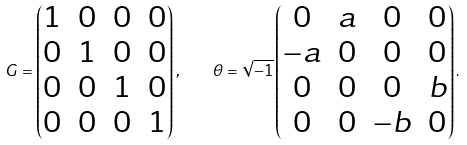<formula> <loc_0><loc_0><loc_500><loc_500>G = \begin{pmatrix} 1 & 0 & 0 & 0 \\ 0 & 1 & 0 & 0 \\ 0 & 0 & 1 & 0 \\ 0 & 0 & 0 & 1 \end{pmatrix} , \quad \theta = \sqrt { - 1 } \begin{pmatrix} 0 & a & 0 & 0 \\ - a & 0 & 0 & 0 \\ 0 & 0 & 0 & b \\ 0 & 0 & - b & 0 \end{pmatrix} .</formula> 